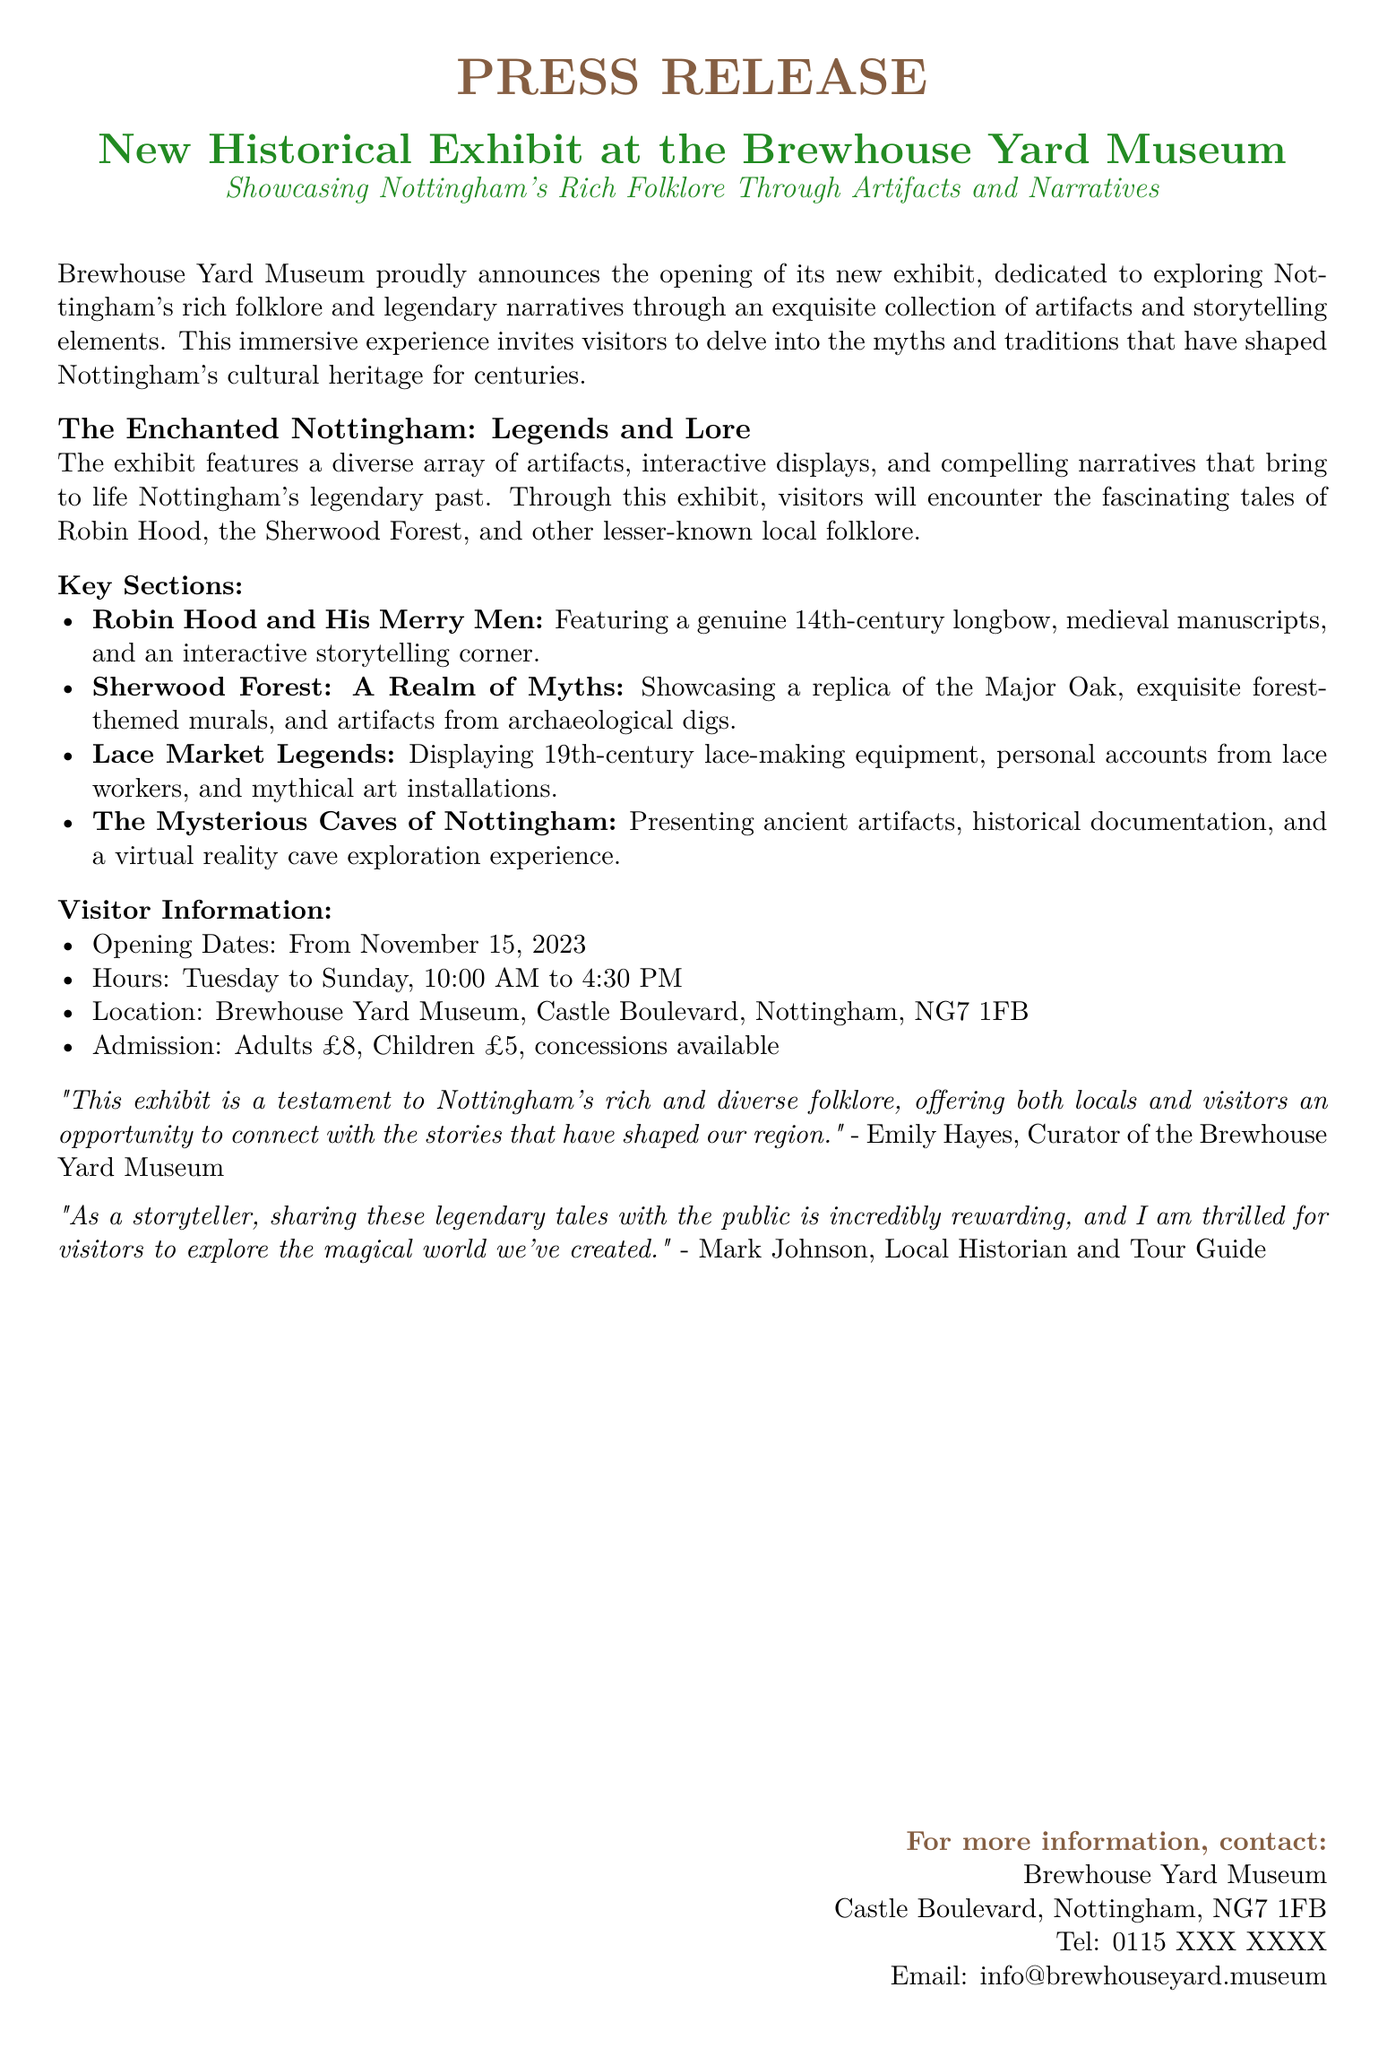What is the title of the exhibit? The title is prominently featured in the document, emphasizing its focus on folklore.
Answer: New Historical Exhibit at the Brewhouse Yard Museum When does the exhibit open? The opening dates are explicitly mentioned in the document.
Answer: November 15, 2023 Where is the Brewhouse Yard Museum located? The location is provided in the visitor information section.
Answer: Castle Boulevard, Nottingham, NG7 1FB What is the admission fee for adults? The document specifies the admission prices clearly.
Answer: £8 Who is the curator of the Brewhouse Yard Museum? The document includes a quote from the curator, providing her name.
Answer: Emily Hayes What artifact represents Robin Hood in the exhibit? The document lists specific artifacts in relation to the legend of Robin Hood.
Answer: 14th-century longbow Which key section features lace-making equipment? The key sections highlight different themes and artifacts, answering this question directly.
Answer: Lace Market Legends What is one interactive experience included in the exhibit? The interactive displays are described in the context of various sections of the exhibit.
Answer: Virtual reality cave exploration experience How many days a week is the museum open? The hours detail the open days of the museum.
Answer: Six days (Tuesday to Sunday) 